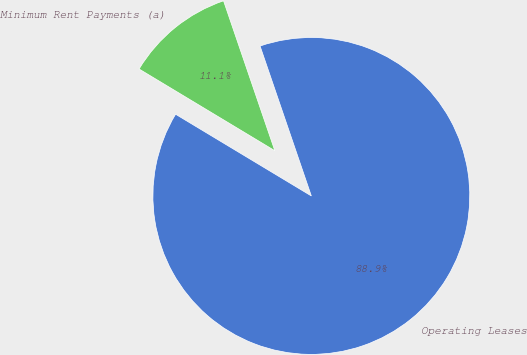Convert chart. <chart><loc_0><loc_0><loc_500><loc_500><pie_chart><fcel>Operating Leases<fcel>Minimum Rent Payments (a)<nl><fcel>88.87%<fcel>11.13%<nl></chart> 